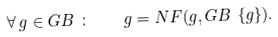<formula> <loc_0><loc_0><loc_500><loc_500>\forall \, g \in G B \ \colon \quad g = N F ( g , G B \ \{ g \} ) .</formula> 